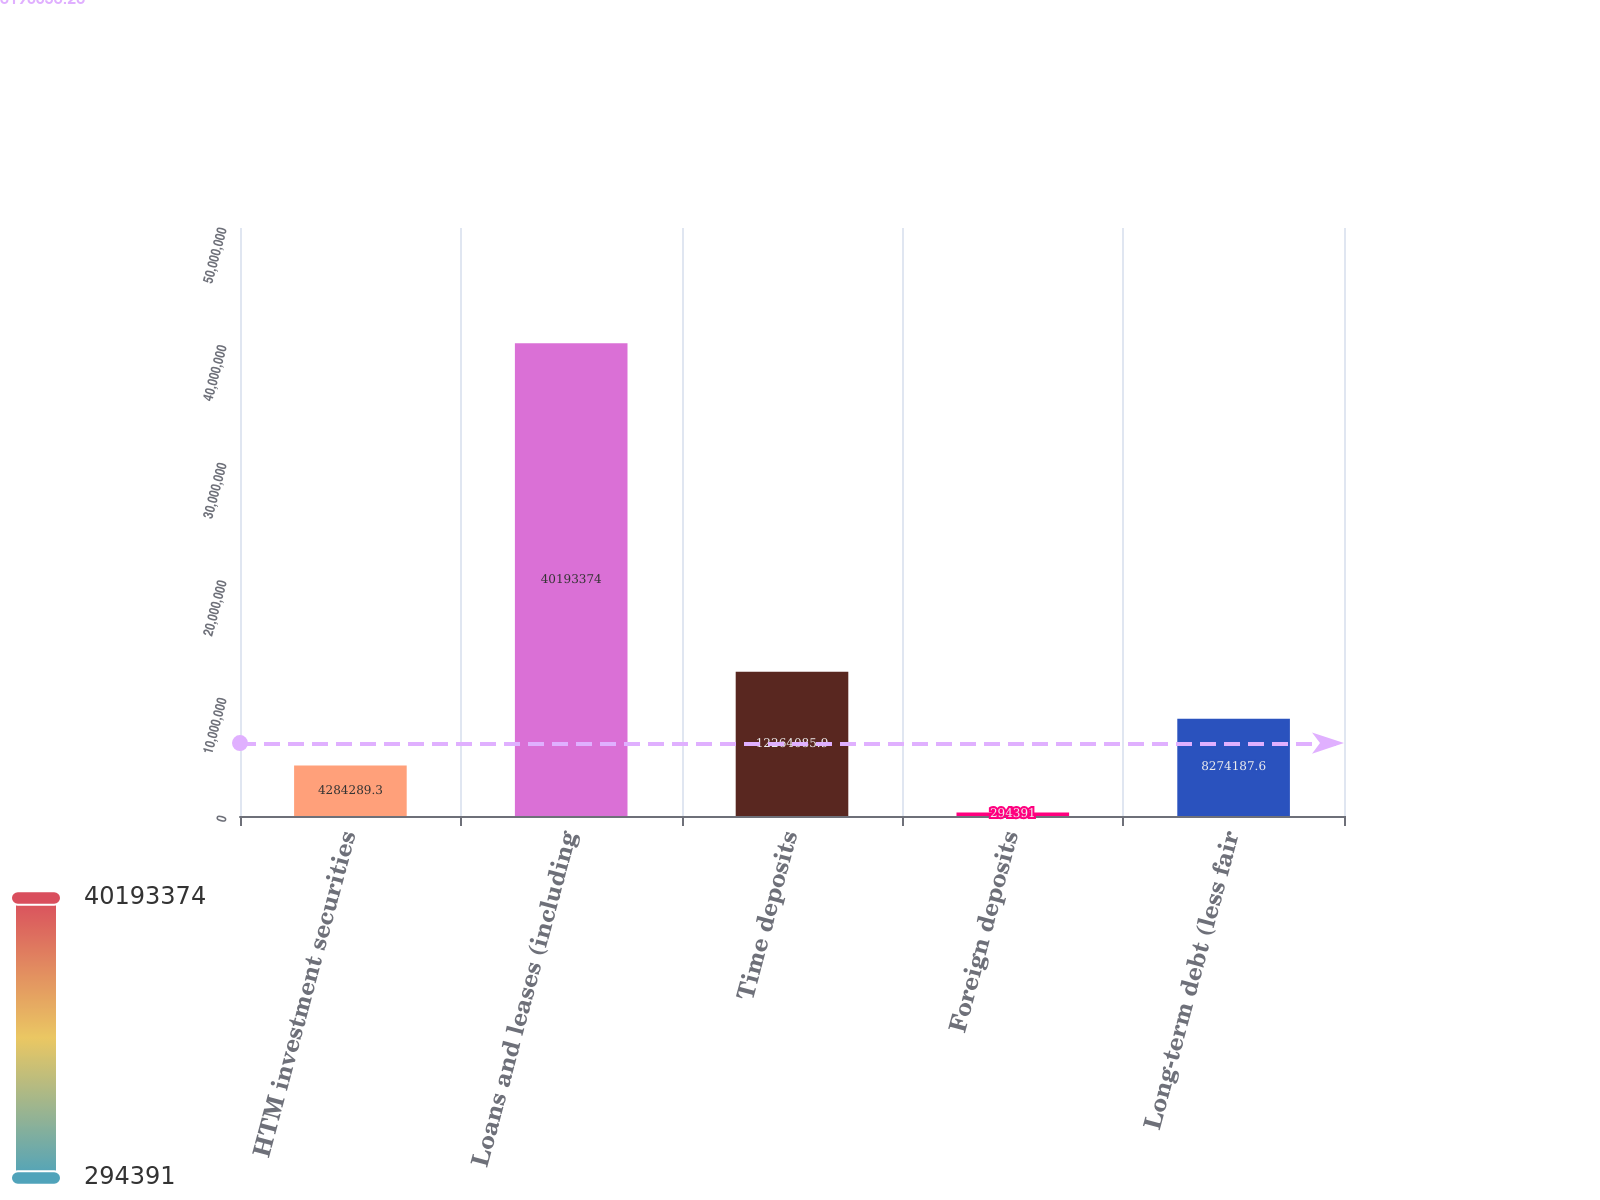<chart> <loc_0><loc_0><loc_500><loc_500><bar_chart><fcel>HTM investment securities<fcel>Loans and leases (including<fcel>Time deposits<fcel>Foreign deposits<fcel>Long-term debt (less fair<nl><fcel>4.28429e+06<fcel>4.01934e+07<fcel>1.22641e+07<fcel>294391<fcel>8.27419e+06<nl></chart> 